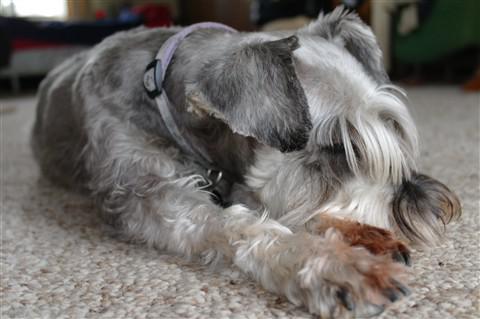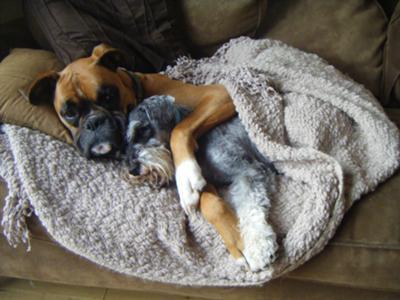The first image is the image on the left, the second image is the image on the right. Evaluate the accuracy of this statement regarding the images: "Each image shows just one dog, and one is lying down, while the other has an upright head and open eyes.". Is it true? Answer yes or no. No. 